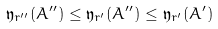<formula> <loc_0><loc_0><loc_500><loc_500>\mathfrak { y } _ { r ^ { \prime \prime } } ( A ^ { \prime \prime } ) \leq \mathfrak { y } _ { r ^ { \prime } } ( A ^ { \prime \prime } ) \leq \mathfrak { y } _ { r ^ { \prime } } ( A ^ { \prime } )</formula> 